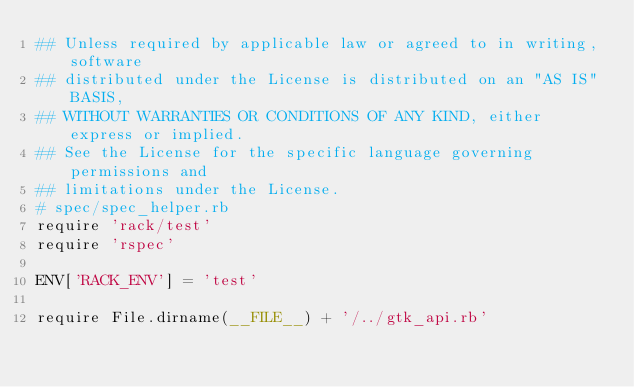Convert code to text. <code><loc_0><loc_0><loc_500><loc_500><_Ruby_>## Unless required by applicable law or agreed to in writing, software
## distributed under the License is distributed on an "AS IS" BASIS,
## WITHOUT WARRANTIES OR CONDITIONS OF ANY KIND, either express or implied.
## See the License for the specific language governing permissions and
## limitations under the License.
# spec/spec_helper.rb
require 'rack/test'
require 'rspec'

ENV['RACK_ENV'] = 'test'

require File.dirname(__FILE__) + '/../gtk_api.rb'</code> 